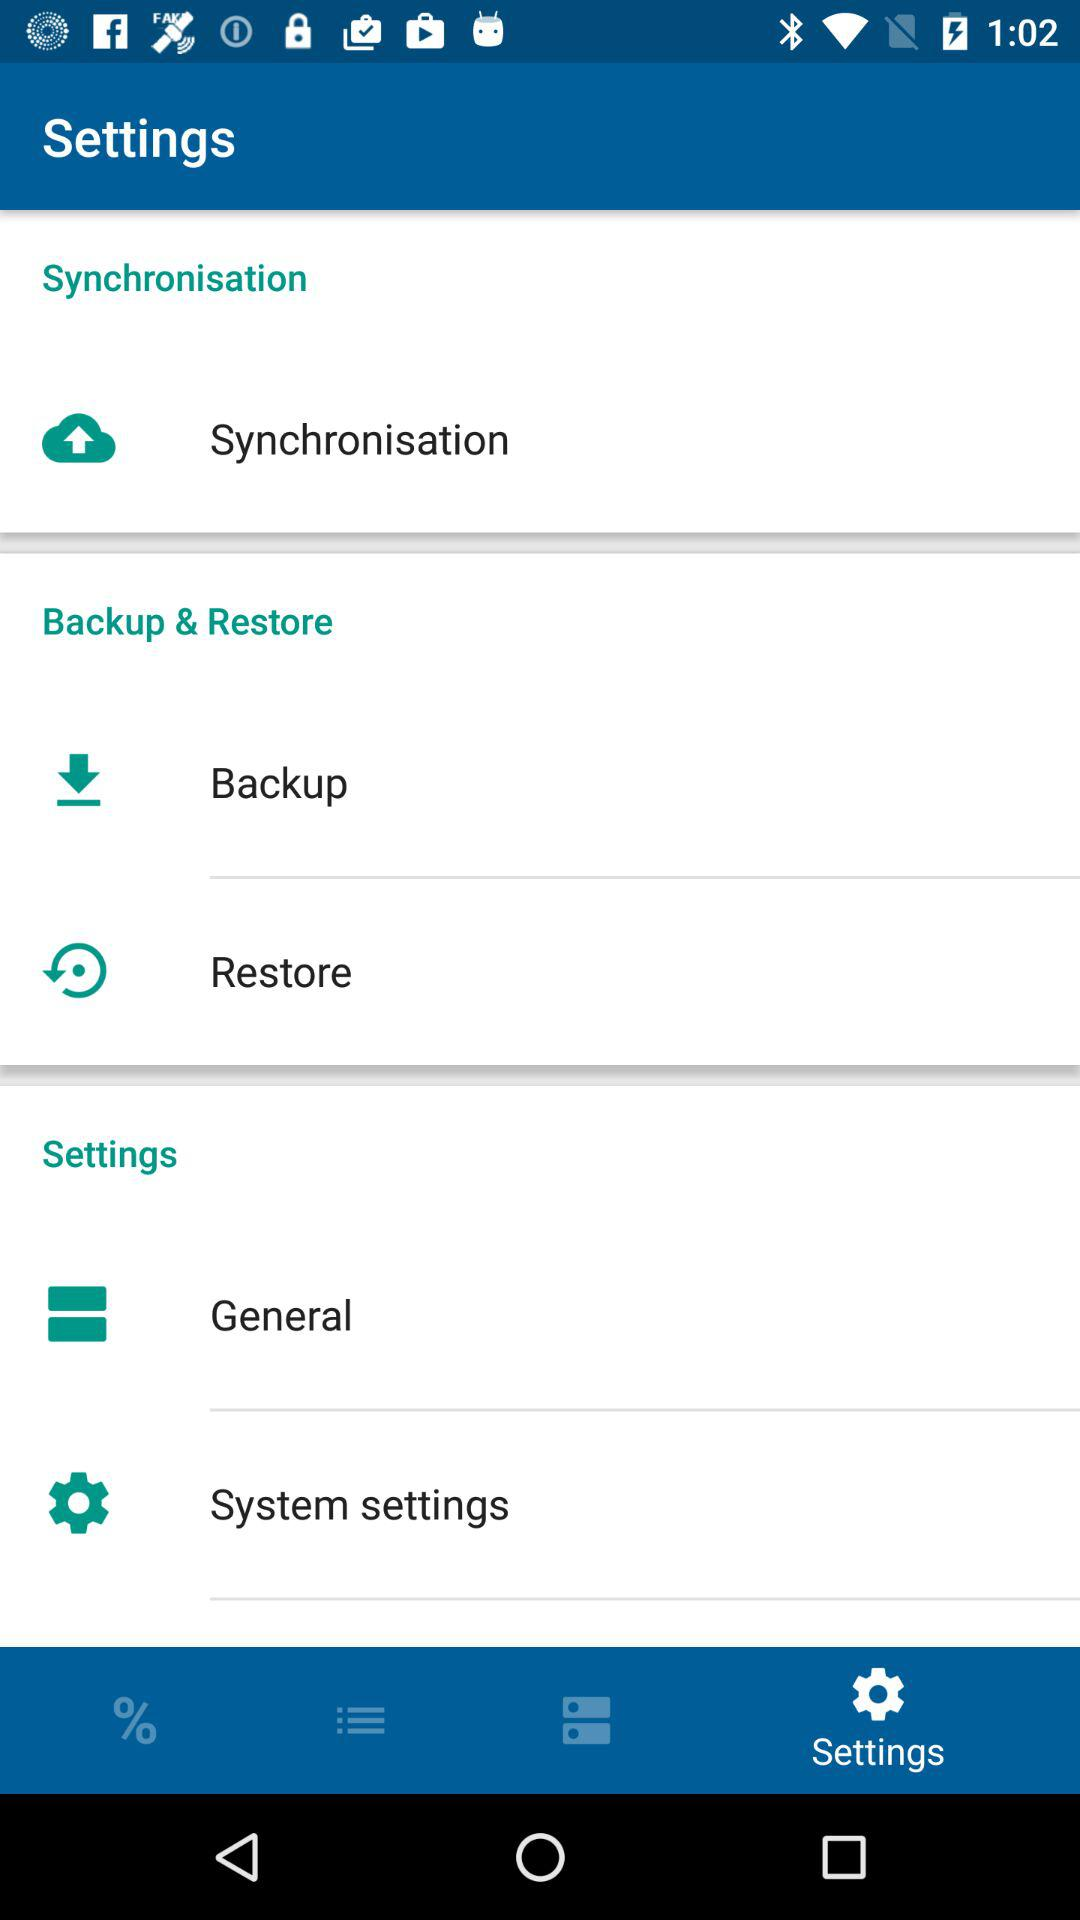How many items are in the backup & restore section?
Answer the question using a single word or phrase. 2 